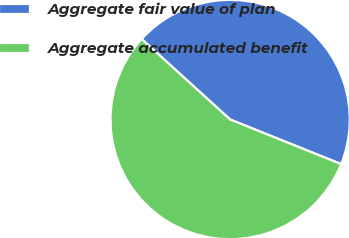<chart> <loc_0><loc_0><loc_500><loc_500><pie_chart><fcel>Aggregate fair value of plan<fcel>Aggregate accumulated benefit<nl><fcel>44.33%<fcel>55.67%<nl></chart> 